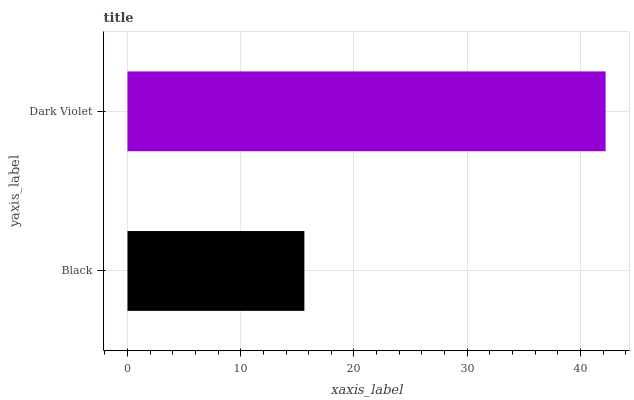Is Black the minimum?
Answer yes or no. Yes. Is Dark Violet the maximum?
Answer yes or no. Yes. Is Dark Violet the minimum?
Answer yes or no. No. Is Dark Violet greater than Black?
Answer yes or no. Yes. Is Black less than Dark Violet?
Answer yes or no. Yes. Is Black greater than Dark Violet?
Answer yes or no. No. Is Dark Violet less than Black?
Answer yes or no. No. Is Dark Violet the high median?
Answer yes or no. Yes. Is Black the low median?
Answer yes or no. Yes. Is Black the high median?
Answer yes or no. No. Is Dark Violet the low median?
Answer yes or no. No. 